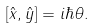<formula> <loc_0><loc_0><loc_500><loc_500>\left [ \hat { x } , \hat { y } \right ] = i \hbar { \theta } .</formula> 